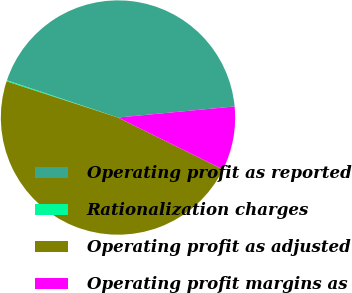Convert chart. <chart><loc_0><loc_0><loc_500><loc_500><pie_chart><fcel>Operating profit as reported<fcel>Rationalization charges<fcel>Operating profit as adjusted<fcel>Operating profit margins as<nl><fcel>43.35%<fcel>0.15%<fcel>47.69%<fcel>8.82%<nl></chart> 